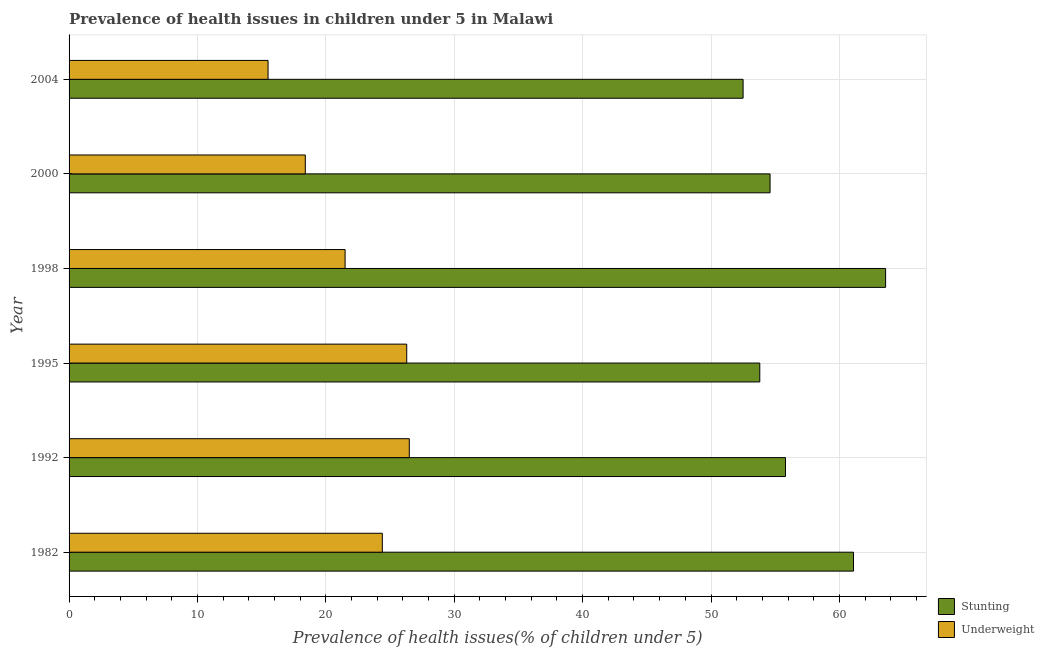How many different coloured bars are there?
Ensure brevity in your answer.  2. How many bars are there on the 1st tick from the bottom?
Offer a terse response. 2. What is the percentage of stunted children in 2000?
Provide a short and direct response. 54.6. Across all years, what is the maximum percentage of underweight children?
Make the answer very short. 26.5. In which year was the percentage of underweight children maximum?
Your answer should be compact. 1992. What is the total percentage of stunted children in the graph?
Your answer should be compact. 341.4. What is the difference between the percentage of underweight children in 2004 and the percentage of stunted children in 2000?
Provide a short and direct response. -39.1. What is the average percentage of underweight children per year?
Give a very brief answer. 22.1. In the year 2000, what is the difference between the percentage of underweight children and percentage of stunted children?
Offer a terse response. -36.2. In how many years, is the percentage of underweight children greater than 18 %?
Ensure brevity in your answer.  5. What is the ratio of the percentage of stunted children in 1982 to that in 1995?
Your answer should be compact. 1.14. Is the percentage of stunted children in 1992 less than that in 1998?
Keep it short and to the point. Yes. Is the difference between the percentage of underweight children in 1982 and 1998 greater than the difference between the percentage of stunted children in 1982 and 1998?
Provide a succinct answer. Yes. What is the difference between the highest and the second highest percentage of underweight children?
Offer a terse response. 0.2. What is the difference between the highest and the lowest percentage of underweight children?
Ensure brevity in your answer.  11. In how many years, is the percentage of stunted children greater than the average percentage of stunted children taken over all years?
Ensure brevity in your answer.  2. Is the sum of the percentage of underweight children in 1982 and 1992 greater than the maximum percentage of stunted children across all years?
Your answer should be very brief. No. What does the 1st bar from the top in 1998 represents?
Give a very brief answer. Underweight. What does the 1st bar from the bottom in 1992 represents?
Ensure brevity in your answer.  Stunting. How many years are there in the graph?
Ensure brevity in your answer.  6. What is the difference between two consecutive major ticks on the X-axis?
Offer a very short reply. 10. Does the graph contain grids?
Offer a very short reply. Yes. Where does the legend appear in the graph?
Your answer should be very brief. Bottom right. How many legend labels are there?
Provide a short and direct response. 2. What is the title of the graph?
Your response must be concise. Prevalence of health issues in children under 5 in Malawi. Does "RDB concessional" appear as one of the legend labels in the graph?
Ensure brevity in your answer.  No. What is the label or title of the X-axis?
Your response must be concise. Prevalence of health issues(% of children under 5). What is the label or title of the Y-axis?
Offer a terse response. Year. What is the Prevalence of health issues(% of children under 5) of Stunting in 1982?
Keep it short and to the point. 61.1. What is the Prevalence of health issues(% of children under 5) in Underweight in 1982?
Your answer should be very brief. 24.4. What is the Prevalence of health issues(% of children under 5) of Stunting in 1992?
Your answer should be very brief. 55.8. What is the Prevalence of health issues(% of children under 5) in Stunting in 1995?
Keep it short and to the point. 53.8. What is the Prevalence of health issues(% of children under 5) in Underweight in 1995?
Offer a very short reply. 26.3. What is the Prevalence of health issues(% of children under 5) of Stunting in 1998?
Give a very brief answer. 63.6. What is the Prevalence of health issues(% of children under 5) in Stunting in 2000?
Ensure brevity in your answer.  54.6. What is the Prevalence of health issues(% of children under 5) of Underweight in 2000?
Offer a terse response. 18.4. What is the Prevalence of health issues(% of children under 5) in Stunting in 2004?
Offer a very short reply. 52.5. What is the Prevalence of health issues(% of children under 5) of Underweight in 2004?
Keep it short and to the point. 15.5. Across all years, what is the maximum Prevalence of health issues(% of children under 5) in Stunting?
Provide a succinct answer. 63.6. Across all years, what is the maximum Prevalence of health issues(% of children under 5) in Underweight?
Keep it short and to the point. 26.5. Across all years, what is the minimum Prevalence of health issues(% of children under 5) in Stunting?
Your response must be concise. 52.5. What is the total Prevalence of health issues(% of children under 5) of Stunting in the graph?
Give a very brief answer. 341.4. What is the total Prevalence of health issues(% of children under 5) in Underweight in the graph?
Your response must be concise. 132.6. What is the difference between the Prevalence of health issues(% of children under 5) of Stunting in 1982 and that in 1998?
Your answer should be compact. -2.5. What is the difference between the Prevalence of health issues(% of children under 5) in Underweight in 1992 and that in 1995?
Ensure brevity in your answer.  0.2. What is the difference between the Prevalence of health issues(% of children under 5) of Stunting in 1992 and that in 1998?
Your answer should be very brief. -7.8. What is the difference between the Prevalence of health issues(% of children under 5) of Stunting in 1992 and that in 2004?
Offer a very short reply. 3.3. What is the difference between the Prevalence of health issues(% of children under 5) of Stunting in 1995 and that in 1998?
Keep it short and to the point. -9.8. What is the difference between the Prevalence of health issues(% of children under 5) of Underweight in 1995 and that in 1998?
Keep it short and to the point. 4.8. What is the difference between the Prevalence of health issues(% of children under 5) in Stunting in 1995 and that in 2004?
Offer a terse response. 1.3. What is the difference between the Prevalence of health issues(% of children under 5) of Stunting in 1998 and that in 2000?
Offer a very short reply. 9. What is the difference between the Prevalence of health issues(% of children under 5) in Stunting in 1982 and the Prevalence of health issues(% of children under 5) in Underweight in 1992?
Offer a terse response. 34.6. What is the difference between the Prevalence of health issues(% of children under 5) in Stunting in 1982 and the Prevalence of health issues(% of children under 5) in Underweight in 1995?
Ensure brevity in your answer.  34.8. What is the difference between the Prevalence of health issues(% of children under 5) in Stunting in 1982 and the Prevalence of health issues(% of children under 5) in Underweight in 1998?
Ensure brevity in your answer.  39.6. What is the difference between the Prevalence of health issues(% of children under 5) in Stunting in 1982 and the Prevalence of health issues(% of children under 5) in Underweight in 2000?
Give a very brief answer. 42.7. What is the difference between the Prevalence of health issues(% of children under 5) of Stunting in 1982 and the Prevalence of health issues(% of children under 5) of Underweight in 2004?
Your answer should be very brief. 45.6. What is the difference between the Prevalence of health issues(% of children under 5) of Stunting in 1992 and the Prevalence of health issues(% of children under 5) of Underweight in 1995?
Make the answer very short. 29.5. What is the difference between the Prevalence of health issues(% of children under 5) in Stunting in 1992 and the Prevalence of health issues(% of children under 5) in Underweight in 1998?
Your answer should be compact. 34.3. What is the difference between the Prevalence of health issues(% of children under 5) of Stunting in 1992 and the Prevalence of health issues(% of children under 5) of Underweight in 2000?
Offer a terse response. 37.4. What is the difference between the Prevalence of health issues(% of children under 5) in Stunting in 1992 and the Prevalence of health issues(% of children under 5) in Underweight in 2004?
Make the answer very short. 40.3. What is the difference between the Prevalence of health issues(% of children under 5) in Stunting in 1995 and the Prevalence of health issues(% of children under 5) in Underweight in 1998?
Offer a terse response. 32.3. What is the difference between the Prevalence of health issues(% of children under 5) of Stunting in 1995 and the Prevalence of health issues(% of children under 5) of Underweight in 2000?
Provide a succinct answer. 35.4. What is the difference between the Prevalence of health issues(% of children under 5) in Stunting in 1995 and the Prevalence of health issues(% of children under 5) in Underweight in 2004?
Provide a short and direct response. 38.3. What is the difference between the Prevalence of health issues(% of children under 5) of Stunting in 1998 and the Prevalence of health issues(% of children under 5) of Underweight in 2000?
Provide a succinct answer. 45.2. What is the difference between the Prevalence of health issues(% of children under 5) in Stunting in 1998 and the Prevalence of health issues(% of children under 5) in Underweight in 2004?
Ensure brevity in your answer.  48.1. What is the difference between the Prevalence of health issues(% of children under 5) in Stunting in 2000 and the Prevalence of health issues(% of children under 5) in Underweight in 2004?
Ensure brevity in your answer.  39.1. What is the average Prevalence of health issues(% of children under 5) in Stunting per year?
Offer a terse response. 56.9. What is the average Prevalence of health issues(% of children under 5) of Underweight per year?
Provide a succinct answer. 22.1. In the year 1982, what is the difference between the Prevalence of health issues(% of children under 5) of Stunting and Prevalence of health issues(% of children under 5) of Underweight?
Ensure brevity in your answer.  36.7. In the year 1992, what is the difference between the Prevalence of health issues(% of children under 5) in Stunting and Prevalence of health issues(% of children under 5) in Underweight?
Your answer should be compact. 29.3. In the year 1995, what is the difference between the Prevalence of health issues(% of children under 5) in Stunting and Prevalence of health issues(% of children under 5) in Underweight?
Your response must be concise. 27.5. In the year 1998, what is the difference between the Prevalence of health issues(% of children under 5) of Stunting and Prevalence of health issues(% of children under 5) of Underweight?
Your answer should be compact. 42.1. In the year 2000, what is the difference between the Prevalence of health issues(% of children under 5) in Stunting and Prevalence of health issues(% of children under 5) in Underweight?
Provide a succinct answer. 36.2. In the year 2004, what is the difference between the Prevalence of health issues(% of children under 5) in Stunting and Prevalence of health issues(% of children under 5) in Underweight?
Offer a terse response. 37. What is the ratio of the Prevalence of health issues(% of children under 5) of Stunting in 1982 to that in 1992?
Ensure brevity in your answer.  1.09. What is the ratio of the Prevalence of health issues(% of children under 5) of Underweight in 1982 to that in 1992?
Your answer should be compact. 0.92. What is the ratio of the Prevalence of health issues(% of children under 5) in Stunting in 1982 to that in 1995?
Your answer should be very brief. 1.14. What is the ratio of the Prevalence of health issues(% of children under 5) of Underweight in 1982 to that in 1995?
Offer a very short reply. 0.93. What is the ratio of the Prevalence of health issues(% of children under 5) in Stunting in 1982 to that in 1998?
Ensure brevity in your answer.  0.96. What is the ratio of the Prevalence of health issues(% of children under 5) in Underweight in 1982 to that in 1998?
Keep it short and to the point. 1.13. What is the ratio of the Prevalence of health issues(% of children under 5) in Stunting in 1982 to that in 2000?
Keep it short and to the point. 1.12. What is the ratio of the Prevalence of health issues(% of children under 5) in Underweight in 1982 to that in 2000?
Offer a terse response. 1.33. What is the ratio of the Prevalence of health issues(% of children under 5) in Stunting in 1982 to that in 2004?
Make the answer very short. 1.16. What is the ratio of the Prevalence of health issues(% of children under 5) of Underweight in 1982 to that in 2004?
Your response must be concise. 1.57. What is the ratio of the Prevalence of health issues(% of children under 5) of Stunting in 1992 to that in 1995?
Give a very brief answer. 1.04. What is the ratio of the Prevalence of health issues(% of children under 5) in Underweight in 1992 to that in 1995?
Offer a terse response. 1.01. What is the ratio of the Prevalence of health issues(% of children under 5) in Stunting in 1992 to that in 1998?
Make the answer very short. 0.88. What is the ratio of the Prevalence of health issues(% of children under 5) of Underweight in 1992 to that in 1998?
Provide a short and direct response. 1.23. What is the ratio of the Prevalence of health issues(% of children under 5) of Underweight in 1992 to that in 2000?
Keep it short and to the point. 1.44. What is the ratio of the Prevalence of health issues(% of children under 5) of Stunting in 1992 to that in 2004?
Your answer should be very brief. 1.06. What is the ratio of the Prevalence of health issues(% of children under 5) of Underweight in 1992 to that in 2004?
Offer a terse response. 1.71. What is the ratio of the Prevalence of health issues(% of children under 5) in Stunting in 1995 to that in 1998?
Ensure brevity in your answer.  0.85. What is the ratio of the Prevalence of health issues(% of children under 5) of Underweight in 1995 to that in 1998?
Offer a very short reply. 1.22. What is the ratio of the Prevalence of health issues(% of children under 5) in Stunting in 1995 to that in 2000?
Your answer should be compact. 0.99. What is the ratio of the Prevalence of health issues(% of children under 5) of Underweight in 1995 to that in 2000?
Your answer should be very brief. 1.43. What is the ratio of the Prevalence of health issues(% of children under 5) of Stunting in 1995 to that in 2004?
Your answer should be very brief. 1.02. What is the ratio of the Prevalence of health issues(% of children under 5) in Underweight in 1995 to that in 2004?
Ensure brevity in your answer.  1.7. What is the ratio of the Prevalence of health issues(% of children under 5) of Stunting in 1998 to that in 2000?
Make the answer very short. 1.16. What is the ratio of the Prevalence of health issues(% of children under 5) in Underweight in 1998 to that in 2000?
Give a very brief answer. 1.17. What is the ratio of the Prevalence of health issues(% of children under 5) of Stunting in 1998 to that in 2004?
Give a very brief answer. 1.21. What is the ratio of the Prevalence of health issues(% of children under 5) in Underweight in 1998 to that in 2004?
Your answer should be compact. 1.39. What is the ratio of the Prevalence of health issues(% of children under 5) in Underweight in 2000 to that in 2004?
Keep it short and to the point. 1.19. What is the difference between the highest and the lowest Prevalence of health issues(% of children under 5) of Underweight?
Provide a short and direct response. 11. 